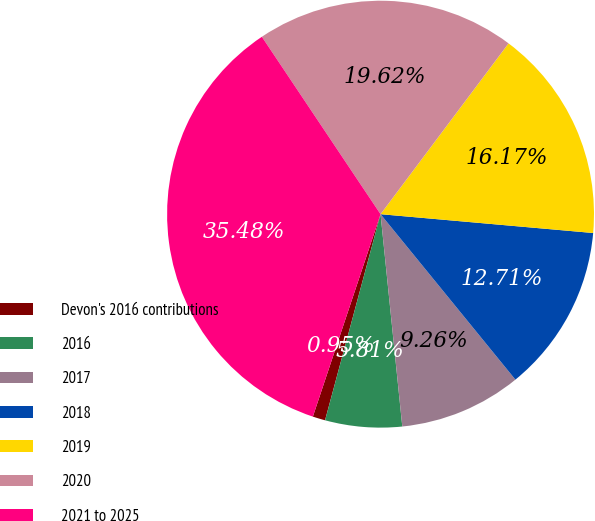Convert chart to OTSL. <chart><loc_0><loc_0><loc_500><loc_500><pie_chart><fcel>Devon's 2016 contributions<fcel>2016<fcel>2017<fcel>2018<fcel>2019<fcel>2020<fcel>2021 to 2025<nl><fcel>0.95%<fcel>5.81%<fcel>9.26%<fcel>12.71%<fcel>16.17%<fcel>19.62%<fcel>35.48%<nl></chart> 